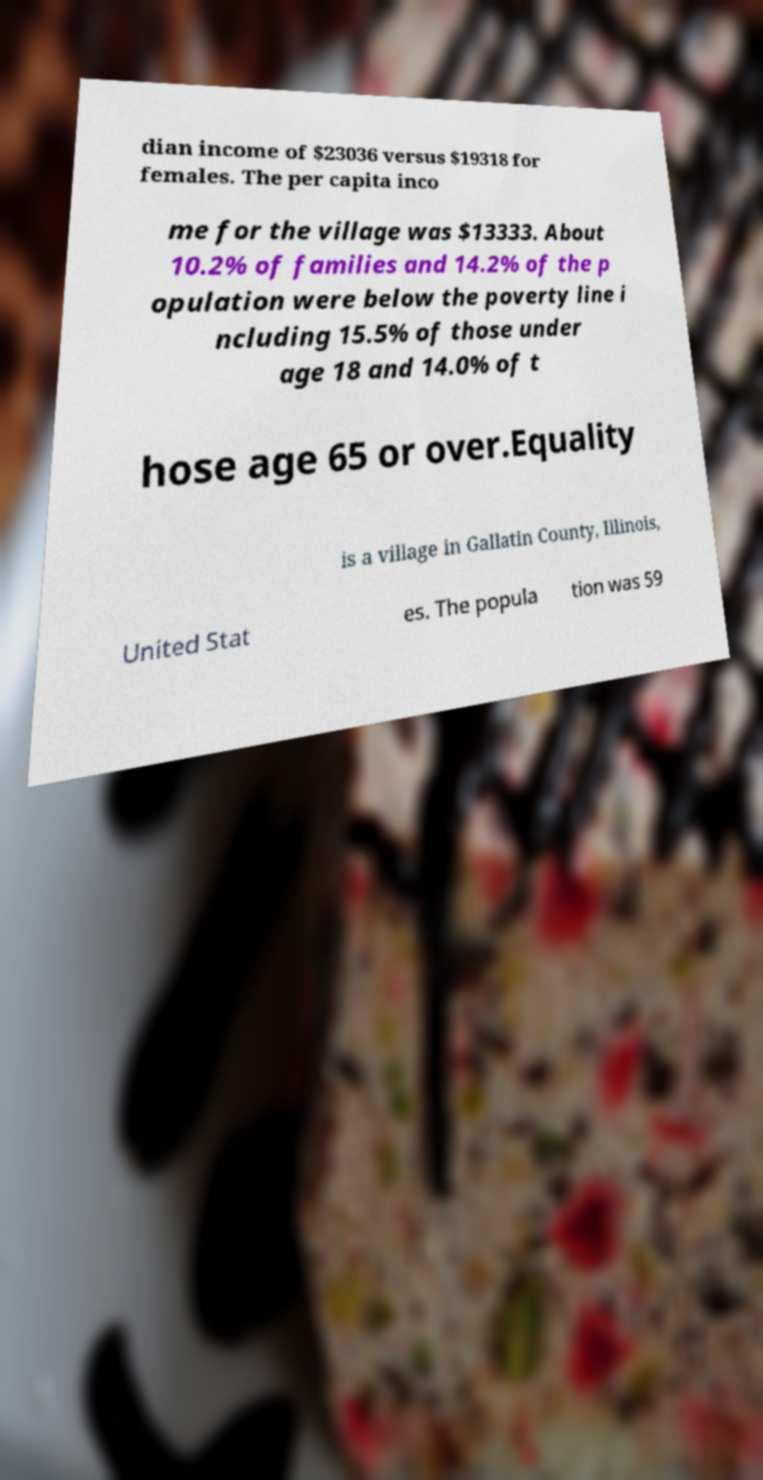Please identify and transcribe the text found in this image. dian income of $23036 versus $19318 for females. The per capita inco me for the village was $13333. About 10.2% of families and 14.2% of the p opulation were below the poverty line i ncluding 15.5% of those under age 18 and 14.0% of t hose age 65 or over.Equality is a village in Gallatin County, Illinois, United Stat es. The popula tion was 59 